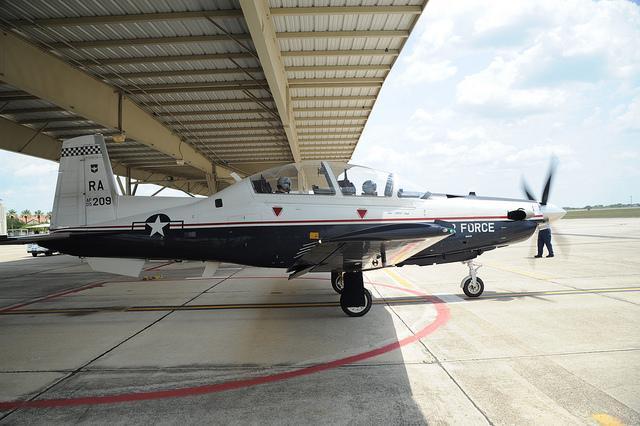How many stars are on the plane?
Give a very brief answer. 1. How many horses in this picture do not have white feet?
Give a very brief answer. 0. 